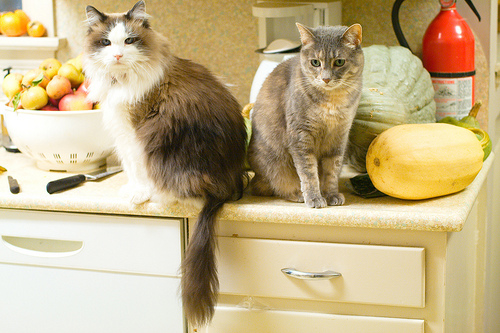<image>
Is the cat to the left of the squash? Yes. From this viewpoint, the cat is positioned to the left side relative to the squash. 